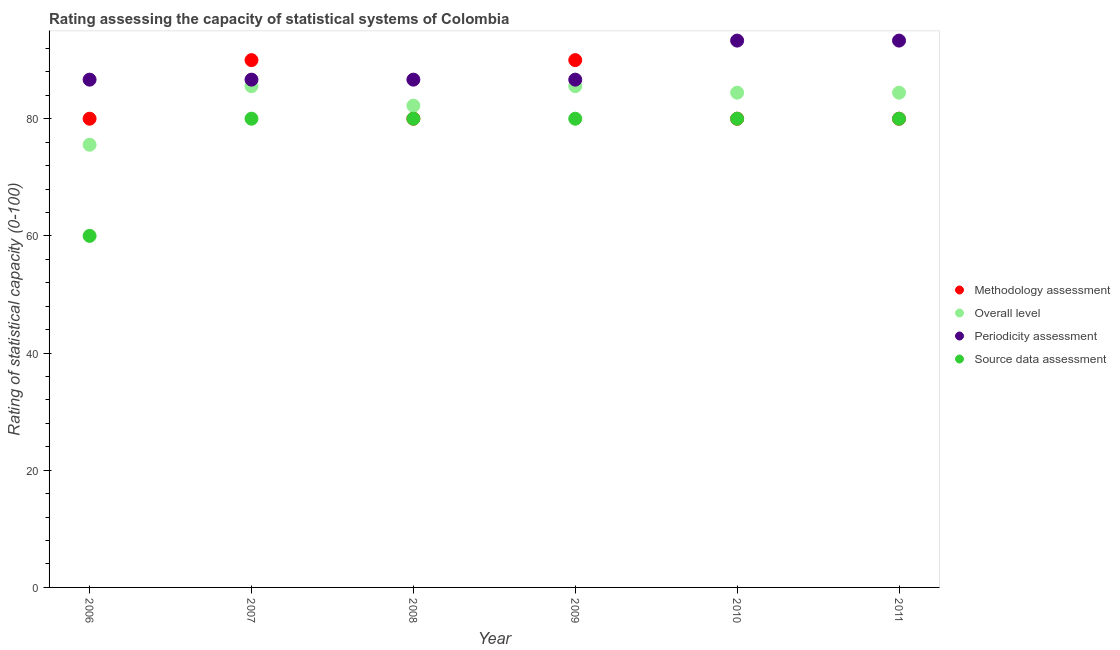What is the methodology assessment rating in 2010?
Your answer should be compact. 80. Across all years, what is the maximum methodology assessment rating?
Keep it short and to the point. 90. Across all years, what is the minimum methodology assessment rating?
Provide a succinct answer. 80. What is the total periodicity assessment rating in the graph?
Give a very brief answer. 533.33. What is the difference between the overall level rating in 2007 and that in 2010?
Your answer should be very brief. 1.11. What is the difference between the periodicity assessment rating in 2010 and the overall level rating in 2008?
Offer a very short reply. 11.11. What is the average periodicity assessment rating per year?
Offer a very short reply. 88.89. In the year 2009, what is the difference between the periodicity assessment rating and overall level rating?
Offer a terse response. 1.11. What is the ratio of the periodicity assessment rating in 2008 to that in 2010?
Offer a terse response. 0.93. Is the difference between the periodicity assessment rating in 2010 and 2011 greater than the difference between the overall level rating in 2010 and 2011?
Your response must be concise. No. What is the difference between the highest and the second highest overall level rating?
Your answer should be very brief. 0. What is the difference between the highest and the lowest source data assessment rating?
Offer a terse response. 20. In how many years, is the source data assessment rating greater than the average source data assessment rating taken over all years?
Give a very brief answer. 5. Is the sum of the overall level rating in 2009 and 2011 greater than the maximum source data assessment rating across all years?
Offer a very short reply. Yes. Is it the case that in every year, the sum of the overall level rating and source data assessment rating is greater than the sum of periodicity assessment rating and methodology assessment rating?
Provide a succinct answer. No. Is it the case that in every year, the sum of the methodology assessment rating and overall level rating is greater than the periodicity assessment rating?
Make the answer very short. Yes. Is the periodicity assessment rating strictly greater than the overall level rating over the years?
Offer a very short reply. Yes. How many dotlines are there?
Give a very brief answer. 4. How many years are there in the graph?
Your answer should be very brief. 6. What is the difference between two consecutive major ticks on the Y-axis?
Give a very brief answer. 20. Are the values on the major ticks of Y-axis written in scientific E-notation?
Ensure brevity in your answer.  No. Does the graph contain any zero values?
Your answer should be very brief. No. Does the graph contain grids?
Your answer should be very brief. No. Where does the legend appear in the graph?
Offer a very short reply. Center right. How many legend labels are there?
Your answer should be very brief. 4. What is the title of the graph?
Make the answer very short. Rating assessing the capacity of statistical systems of Colombia. What is the label or title of the X-axis?
Provide a short and direct response. Year. What is the label or title of the Y-axis?
Your answer should be compact. Rating of statistical capacity (0-100). What is the Rating of statistical capacity (0-100) in Methodology assessment in 2006?
Your response must be concise. 80. What is the Rating of statistical capacity (0-100) of Overall level in 2006?
Offer a terse response. 75.56. What is the Rating of statistical capacity (0-100) in Periodicity assessment in 2006?
Keep it short and to the point. 86.67. What is the Rating of statistical capacity (0-100) of Methodology assessment in 2007?
Your response must be concise. 90. What is the Rating of statistical capacity (0-100) of Overall level in 2007?
Provide a short and direct response. 85.56. What is the Rating of statistical capacity (0-100) in Periodicity assessment in 2007?
Keep it short and to the point. 86.67. What is the Rating of statistical capacity (0-100) of Methodology assessment in 2008?
Give a very brief answer. 80. What is the Rating of statistical capacity (0-100) in Overall level in 2008?
Provide a succinct answer. 82.22. What is the Rating of statistical capacity (0-100) of Periodicity assessment in 2008?
Keep it short and to the point. 86.67. What is the Rating of statistical capacity (0-100) in Source data assessment in 2008?
Ensure brevity in your answer.  80. What is the Rating of statistical capacity (0-100) in Overall level in 2009?
Keep it short and to the point. 85.56. What is the Rating of statistical capacity (0-100) in Periodicity assessment in 2009?
Give a very brief answer. 86.67. What is the Rating of statistical capacity (0-100) in Overall level in 2010?
Your response must be concise. 84.44. What is the Rating of statistical capacity (0-100) in Periodicity assessment in 2010?
Offer a terse response. 93.33. What is the Rating of statistical capacity (0-100) of Source data assessment in 2010?
Keep it short and to the point. 80. What is the Rating of statistical capacity (0-100) in Overall level in 2011?
Make the answer very short. 84.44. What is the Rating of statistical capacity (0-100) of Periodicity assessment in 2011?
Give a very brief answer. 93.33. Across all years, what is the maximum Rating of statistical capacity (0-100) in Overall level?
Ensure brevity in your answer.  85.56. Across all years, what is the maximum Rating of statistical capacity (0-100) of Periodicity assessment?
Offer a very short reply. 93.33. Across all years, what is the maximum Rating of statistical capacity (0-100) in Source data assessment?
Give a very brief answer. 80. Across all years, what is the minimum Rating of statistical capacity (0-100) of Overall level?
Offer a terse response. 75.56. Across all years, what is the minimum Rating of statistical capacity (0-100) of Periodicity assessment?
Your response must be concise. 86.67. What is the total Rating of statistical capacity (0-100) in Methodology assessment in the graph?
Your response must be concise. 500. What is the total Rating of statistical capacity (0-100) of Overall level in the graph?
Your response must be concise. 497.78. What is the total Rating of statistical capacity (0-100) in Periodicity assessment in the graph?
Give a very brief answer. 533.33. What is the total Rating of statistical capacity (0-100) in Source data assessment in the graph?
Your answer should be very brief. 460. What is the difference between the Rating of statistical capacity (0-100) in Overall level in 2006 and that in 2007?
Make the answer very short. -10. What is the difference between the Rating of statistical capacity (0-100) of Methodology assessment in 2006 and that in 2008?
Offer a terse response. 0. What is the difference between the Rating of statistical capacity (0-100) in Overall level in 2006 and that in 2008?
Make the answer very short. -6.67. What is the difference between the Rating of statistical capacity (0-100) of Source data assessment in 2006 and that in 2008?
Provide a succinct answer. -20. What is the difference between the Rating of statistical capacity (0-100) in Methodology assessment in 2006 and that in 2009?
Provide a short and direct response. -10. What is the difference between the Rating of statistical capacity (0-100) of Methodology assessment in 2006 and that in 2010?
Ensure brevity in your answer.  0. What is the difference between the Rating of statistical capacity (0-100) in Overall level in 2006 and that in 2010?
Keep it short and to the point. -8.89. What is the difference between the Rating of statistical capacity (0-100) in Periodicity assessment in 2006 and that in 2010?
Offer a very short reply. -6.67. What is the difference between the Rating of statistical capacity (0-100) in Source data assessment in 2006 and that in 2010?
Provide a short and direct response. -20. What is the difference between the Rating of statistical capacity (0-100) in Methodology assessment in 2006 and that in 2011?
Provide a short and direct response. 0. What is the difference between the Rating of statistical capacity (0-100) of Overall level in 2006 and that in 2011?
Provide a succinct answer. -8.89. What is the difference between the Rating of statistical capacity (0-100) in Periodicity assessment in 2006 and that in 2011?
Ensure brevity in your answer.  -6.67. What is the difference between the Rating of statistical capacity (0-100) in Source data assessment in 2007 and that in 2008?
Offer a terse response. 0. What is the difference between the Rating of statistical capacity (0-100) in Methodology assessment in 2007 and that in 2009?
Your response must be concise. 0. What is the difference between the Rating of statistical capacity (0-100) in Overall level in 2007 and that in 2009?
Keep it short and to the point. 0. What is the difference between the Rating of statistical capacity (0-100) in Periodicity assessment in 2007 and that in 2009?
Your response must be concise. 0. What is the difference between the Rating of statistical capacity (0-100) in Periodicity assessment in 2007 and that in 2010?
Make the answer very short. -6.67. What is the difference between the Rating of statistical capacity (0-100) in Methodology assessment in 2007 and that in 2011?
Make the answer very short. 10. What is the difference between the Rating of statistical capacity (0-100) in Overall level in 2007 and that in 2011?
Provide a short and direct response. 1.11. What is the difference between the Rating of statistical capacity (0-100) of Periodicity assessment in 2007 and that in 2011?
Ensure brevity in your answer.  -6.67. What is the difference between the Rating of statistical capacity (0-100) of Source data assessment in 2007 and that in 2011?
Keep it short and to the point. 0. What is the difference between the Rating of statistical capacity (0-100) of Methodology assessment in 2008 and that in 2009?
Your answer should be compact. -10. What is the difference between the Rating of statistical capacity (0-100) of Overall level in 2008 and that in 2009?
Ensure brevity in your answer.  -3.33. What is the difference between the Rating of statistical capacity (0-100) of Source data assessment in 2008 and that in 2009?
Ensure brevity in your answer.  0. What is the difference between the Rating of statistical capacity (0-100) of Methodology assessment in 2008 and that in 2010?
Make the answer very short. 0. What is the difference between the Rating of statistical capacity (0-100) in Overall level in 2008 and that in 2010?
Your answer should be compact. -2.22. What is the difference between the Rating of statistical capacity (0-100) in Periodicity assessment in 2008 and that in 2010?
Your answer should be compact. -6.67. What is the difference between the Rating of statistical capacity (0-100) of Source data assessment in 2008 and that in 2010?
Give a very brief answer. 0. What is the difference between the Rating of statistical capacity (0-100) of Overall level in 2008 and that in 2011?
Provide a succinct answer. -2.22. What is the difference between the Rating of statistical capacity (0-100) of Periodicity assessment in 2008 and that in 2011?
Keep it short and to the point. -6.67. What is the difference between the Rating of statistical capacity (0-100) of Methodology assessment in 2009 and that in 2010?
Keep it short and to the point. 10. What is the difference between the Rating of statistical capacity (0-100) in Overall level in 2009 and that in 2010?
Offer a terse response. 1.11. What is the difference between the Rating of statistical capacity (0-100) in Periodicity assessment in 2009 and that in 2010?
Your response must be concise. -6.67. What is the difference between the Rating of statistical capacity (0-100) in Overall level in 2009 and that in 2011?
Your answer should be compact. 1.11. What is the difference between the Rating of statistical capacity (0-100) in Periodicity assessment in 2009 and that in 2011?
Provide a short and direct response. -6.67. What is the difference between the Rating of statistical capacity (0-100) in Overall level in 2010 and that in 2011?
Your response must be concise. 0. What is the difference between the Rating of statistical capacity (0-100) in Methodology assessment in 2006 and the Rating of statistical capacity (0-100) in Overall level in 2007?
Keep it short and to the point. -5.56. What is the difference between the Rating of statistical capacity (0-100) in Methodology assessment in 2006 and the Rating of statistical capacity (0-100) in Periodicity assessment in 2007?
Offer a very short reply. -6.67. What is the difference between the Rating of statistical capacity (0-100) in Methodology assessment in 2006 and the Rating of statistical capacity (0-100) in Source data assessment in 2007?
Provide a short and direct response. 0. What is the difference between the Rating of statistical capacity (0-100) of Overall level in 2006 and the Rating of statistical capacity (0-100) of Periodicity assessment in 2007?
Give a very brief answer. -11.11. What is the difference between the Rating of statistical capacity (0-100) in Overall level in 2006 and the Rating of statistical capacity (0-100) in Source data assessment in 2007?
Your answer should be compact. -4.44. What is the difference between the Rating of statistical capacity (0-100) in Methodology assessment in 2006 and the Rating of statistical capacity (0-100) in Overall level in 2008?
Provide a succinct answer. -2.22. What is the difference between the Rating of statistical capacity (0-100) of Methodology assessment in 2006 and the Rating of statistical capacity (0-100) of Periodicity assessment in 2008?
Keep it short and to the point. -6.67. What is the difference between the Rating of statistical capacity (0-100) in Overall level in 2006 and the Rating of statistical capacity (0-100) in Periodicity assessment in 2008?
Make the answer very short. -11.11. What is the difference between the Rating of statistical capacity (0-100) in Overall level in 2006 and the Rating of statistical capacity (0-100) in Source data assessment in 2008?
Keep it short and to the point. -4.44. What is the difference between the Rating of statistical capacity (0-100) of Periodicity assessment in 2006 and the Rating of statistical capacity (0-100) of Source data assessment in 2008?
Provide a succinct answer. 6.67. What is the difference between the Rating of statistical capacity (0-100) of Methodology assessment in 2006 and the Rating of statistical capacity (0-100) of Overall level in 2009?
Give a very brief answer. -5.56. What is the difference between the Rating of statistical capacity (0-100) in Methodology assessment in 2006 and the Rating of statistical capacity (0-100) in Periodicity assessment in 2009?
Make the answer very short. -6.67. What is the difference between the Rating of statistical capacity (0-100) of Overall level in 2006 and the Rating of statistical capacity (0-100) of Periodicity assessment in 2009?
Keep it short and to the point. -11.11. What is the difference between the Rating of statistical capacity (0-100) in Overall level in 2006 and the Rating of statistical capacity (0-100) in Source data assessment in 2009?
Offer a terse response. -4.44. What is the difference between the Rating of statistical capacity (0-100) in Methodology assessment in 2006 and the Rating of statistical capacity (0-100) in Overall level in 2010?
Your response must be concise. -4.44. What is the difference between the Rating of statistical capacity (0-100) in Methodology assessment in 2006 and the Rating of statistical capacity (0-100) in Periodicity assessment in 2010?
Make the answer very short. -13.33. What is the difference between the Rating of statistical capacity (0-100) in Overall level in 2006 and the Rating of statistical capacity (0-100) in Periodicity assessment in 2010?
Offer a very short reply. -17.78. What is the difference between the Rating of statistical capacity (0-100) in Overall level in 2006 and the Rating of statistical capacity (0-100) in Source data assessment in 2010?
Provide a short and direct response. -4.44. What is the difference between the Rating of statistical capacity (0-100) in Methodology assessment in 2006 and the Rating of statistical capacity (0-100) in Overall level in 2011?
Make the answer very short. -4.44. What is the difference between the Rating of statistical capacity (0-100) in Methodology assessment in 2006 and the Rating of statistical capacity (0-100) in Periodicity assessment in 2011?
Provide a short and direct response. -13.33. What is the difference between the Rating of statistical capacity (0-100) of Overall level in 2006 and the Rating of statistical capacity (0-100) of Periodicity assessment in 2011?
Your answer should be very brief. -17.78. What is the difference between the Rating of statistical capacity (0-100) of Overall level in 2006 and the Rating of statistical capacity (0-100) of Source data assessment in 2011?
Keep it short and to the point. -4.44. What is the difference between the Rating of statistical capacity (0-100) of Periodicity assessment in 2006 and the Rating of statistical capacity (0-100) of Source data assessment in 2011?
Make the answer very short. 6.67. What is the difference between the Rating of statistical capacity (0-100) of Methodology assessment in 2007 and the Rating of statistical capacity (0-100) of Overall level in 2008?
Offer a terse response. 7.78. What is the difference between the Rating of statistical capacity (0-100) in Methodology assessment in 2007 and the Rating of statistical capacity (0-100) in Periodicity assessment in 2008?
Your answer should be very brief. 3.33. What is the difference between the Rating of statistical capacity (0-100) of Methodology assessment in 2007 and the Rating of statistical capacity (0-100) of Source data assessment in 2008?
Your answer should be very brief. 10. What is the difference between the Rating of statistical capacity (0-100) of Overall level in 2007 and the Rating of statistical capacity (0-100) of Periodicity assessment in 2008?
Offer a terse response. -1.11. What is the difference between the Rating of statistical capacity (0-100) of Overall level in 2007 and the Rating of statistical capacity (0-100) of Source data assessment in 2008?
Your answer should be very brief. 5.56. What is the difference between the Rating of statistical capacity (0-100) of Periodicity assessment in 2007 and the Rating of statistical capacity (0-100) of Source data assessment in 2008?
Keep it short and to the point. 6.67. What is the difference between the Rating of statistical capacity (0-100) in Methodology assessment in 2007 and the Rating of statistical capacity (0-100) in Overall level in 2009?
Your response must be concise. 4.44. What is the difference between the Rating of statistical capacity (0-100) in Methodology assessment in 2007 and the Rating of statistical capacity (0-100) in Periodicity assessment in 2009?
Provide a short and direct response. 3.33. What is the difference between the Rating of statistical capacity (0-100) in Overall level in 2007 and the Rating of statistical capacity (0-100) in Periodicity assessment in 2009?
Provide a short and direct response. -1.11. What is the difference between the Rating of statistical capacity (0-100) of Overall level in 2007 and the Rating of statistical capacity (0-100) of Source data assessment in 2009?
Your answer should be compact. 5.56. What is the difference between the Rating of statistical capacity (0-100) in Periodicity assessment in 2007 and the Rating of statistical capacity (0-100) in Source data assessment in 2009?
Give a very brief answer. 6.67. What is the difference between the Rating of statistical capacity (0-100) of Methodology assessment in 2007 and the Rating of statistical capacity (0-100) of Overall level in 2010?
Offer a very short reply. 5.56. What is the difference between the Rating of statistical capacity (0-100) in Overall level in 2007 and the Rating of statistical capacity (0-100) in Periodicity assessment in 2010?
Offer a terse response. -7.78. What is the difference between the Rating of statistical capacity (0-100) of Overall level in 2007 and the Rating of statistical capacity (0-100) of Source data assessment in 2010?
Offer a very short reply. 5.56. What is the difference between the Rating of statistical capacity (0-100) in Periodicity assessment in 2007 and the Rating of statistical capacity (0-100) in Source data assessment in 2010?
Offer a terse response. 6.67. What is the difference between the Rating of statistical capacity (0-100) in Methodology assessment in 2007 and the Rating of statistical capacity (0-100) in Overall level in 2011?
Provide a short and direct response. 5.56. What is the difference between the Rating of statistical capacity (0-100) in Methodology assessment in 2007 and the Rating of statistical capacity (0-100) in Periodicity assessment in 2011?
Your answer should be very brief. -3.33. What is the difference between the Rating of statistical capacity (0-100) in Overall level in 2007 and the Rating of statistical capacity (0-100) in Periodicity assessment in 2011?
Your answer should be compact. -7.78. What is the difference between the Rating of statistical capacity (0-100) of Overall level in 2007 and the Rating of statistical capacity (0-100) of Source data assessment in 2011?
Make the answer very short. 5.56. What is the difference between the Rating of statistical capacity (0-100) in Periodicity assessment in 2007 and the Rating of statistical capacity (0-100) in Source data assessment in 2011?
Give a very brief answer. 6.67. What is the difference between the Rating of statistical capacity (0-100) in Methodology assessment in 2008 and the Rating of statistical capacity (0-100) in Overall level in 2009?
Provide a short and direct response. -5.56. What is the difference between the Rating of statistical capacity (0-100) of Methodology assessment in 2008 and the Rating of statistical capacity (0-100) of Periodicity assessment in 2009?
Your answer should be compact. -6.67. What is the difference between the Rating of statistical capacity (0-100) in Methodology assessment in 2008 and the Rating of statistical capacity (0-100) in Source data assessment in 2009?
Your response must be concise. 0. What is the difference between the Rating of statistical capacity (0-100) in Overall level in 2008 and the Rating of statistical capacity (0-100) in Periodicity assessment in 2009?
Offer a very short reply. -4.44. What is the difference between the Rating of statistical capacity (0-100) in Overall level in 2008 and the Rating of statistical capacity (0-100) in Source data assessment in 2009?
Your answer should be compact. 2.22. What is the difference between the Rating of statistical capacity (0-100) in Methodology assessment in 2008 and the Rating of statistical capacity (0-100) in Overall level in 2010?
Make the answer very short. -4.44. What is the difference between the Rating of statistical capacity (0-100) in Methodology assessment in 2008 and the Rating of statistical capacity (0-100) in Periodicity assessment in 2010?
Offer a very short reply. -13.33. What is the difference between the Rating of statistical capacity (0-100) in Methodology assessment in 2008 and the Rating of statistical capacity (0-100) in Source data assessment in 2010?
Keep it short and to the point. 0. What is the difference between the Rating of statistical capacity (0-100) in Overall level in 2008 and the Rating of statistical capacity (0-100) in Periodicity assessment in 2010?
Offer a very short reply. -11.11. What is the difference between the Rating of statistical capacity (0-100) of Overall level in 2008 and the Rating of statistical capacity (0-100) of Source data assessment in 2010?
Give a very brief answer. 2.22. What is the difference between the Rating of statistical capacity (0-100) in Methodology assessment in 2008 and the Rating of statistical capacity (0-100) in Overall level in 2011?
Provide a short and direct response. -4.44. What is the difference between the Rating of statistical capacity (0-100) in Methodology assessment in 2008 and the Rating of statistical capacity (0-100) in Periodicity assessment in 2011?
Make the answer very short. -13.33. What is the difference between the Rating of statistical capacity (0-100) of Overall level in 2008 and the Rating of statistical capacity (0-100) of Periodicity assessment in 2011?
Your answer should be compact. -11.11. What is the difference between the Rating of statistical capacity (0-100) in Overall level in 2008 and the Rating of statistical capacity (0-100) in Source data assessment in 2011?
Provide a short and direct response. 2.22. What is the difference between the Rating of statistical capacity (0-100) in Periodicity assessment in 2008 and the Rating of statistical capacity (0-100) in Source data assessment in 2011?
Offer a terse response. 6.67. What is the difference between the Rating of statistical capacity (0-100) of Methodology assessment in 2009 and the Rating of statistical capacity (0-100) of Overall level in 2010?
Give a very brief answer. 5.56. What is the difference between the Rating of statistical capacity (0-100) in Methodology assessment in 2009 and the Rating of statistical capacity (0-100) in Source data assessment in 2010?
Your response must be concise. 10. What is the difference between the Rating of statistical capacity (0-100) in Overall level in 2009 and the Rating of statistical capacity (0-100) in Periodicity assessment in 2010?
Ensure brevity in your answer.  -7.78. What is the difference between the Rating of statistical capacity (0-100) of Overall level in 2009 and the Rating of statistical capacity (0-100) of Source data assessment in 2010?
Make the answer very short. 5.56. What is the difference between the Rating of statistical capacity (0-100) of Methodology assessment in 2009 and the Rating of statistical capacity (0-100) of Overall level in 2011?
Your answer should be very brief. 5.56. What is the difference between the Rating of statistical capacity (0-100) in Methodology assessment in 2009 and the Rating of statistical capacity (0-100) in Periodicity assessment in 2011?
Your response must be concise. -3.33. What is the difference between the Rating of statistical capacity (0-100) in Methodology assessment in 2009 and the Rating of statistical capacity (0-100) in Source data assessment in 2011?
Offer a very short reply. 10. What is the difference between the Rating of statistical capacity (0-100) of Overall level in 2009 and the Rating of statistical capacity (0-100) of Periodicity assessment in 2011?
Make the answer very short. -7.78. What is the difference between the Rating of statistical capacity (0-100) in Overall level in 2009 and the Rating of statistical capacity (0-100) in Source data assessment in 2011?
Keep it short and to the point. 5.56. What is the difference between the Rating of statistical capacity (0-100) of Periodicity assessment in 2009 and the Rating of statistical capacity (0-100) of Source data assessment in 2011?
Your response must be concise. 6.67. What is the difference between the Rating of statistical capacity (0-100) of Methodology assessment in 2010 and the Rating of statistical capacity (0-100) of Overall level in 2011?
Keep it short and to the point. -4.44. What is the difference between the Rating of statistical capacity (0-100) of Methodology assessment in 2010 and the Rating of statistical capacity (0-100) of Periodicity assessment in 2011?
Ensure brevity in your answer.  -13.33. What is the difference between the Rating of statistical capacity (0-100) of Overall level in 2010 and the Rating of statistical capacity (0-100) of Periodicity assessment in 2011?
Make the answer very short. -8.89. What is the difference between the Rating of statistical capacity (0-100) in Overall level in 2010 and the Rating of statistical capacity (0-100) in Source data assessment in 2011?
Provide a succinct answer. 4.44. What is the difference between the Rating of statistical capacity (0-100) in Periodicity assessment in 2010 and the Rating of statistical capacity (0-100) in Source data assessment in 2011?
Provide a short and direct response. 13.33. What is the average Rating of statistical capacity (0-100) in Methodology assessment per year?
Keep it short and to the point. 83.33. What is the average Rating of statistical capacity (0-100) of Overall level per year?
Offer a terse response. 82.96. What is the average Rating of statistical capacity (0-100) in Periodicity assessment per year?
Provide a succinct answer. 88.89. What is the average Rating of statistical capacity (0-100) of Source data assessment per year?
Ensure brevity in your answer.  76.67. In the year 2006, what is the difference between the Rating of statistical capacity (0-100) of Methodology assessment and Rating of statistical capacity (0-100) of Overall level?
Keep it short and to the point. 4.44. In the year 2006, what is the difference between the Rating of statistical capacity (0-100) of Methodology assessment and Rating of statistical capacity (0-100) of Periodicity assessment?
Keep it short and to the point. -6.67. In the year 2006, what is the difference between the Rating of statistical capacity (0-100) in Methodology assessment and Rating of statistical capacity (0-100) in Source data assessment?
Provide a succinct answer. 20. In the year 2006, what is the difference between the Rating of statistical capacity (0-100) in Overall level and Rating of statistical capacity (0-100) in Periodicity assessment?
Your answer should be compact. -11.11. In the year 2006, what is the difference between the Rating of statistical capacity (0-100) in Overall level and Rating of statistical capacity (0-100) in Source data assessment?
Your answer should be very brief. 15.56. In the year 2006, what is the difference between the Rating of statistical capacity (0-100) of Periodicity assessment and Rating of statistical capacity (0-100) of Source data assessment?
Provide a succinct answer. 26.67. In the year 2007, what is the difference between the Rating of statistical capacity (0-100) in Methodology assessment and Rating of statistical capacity (0-100) in Overall level?
Provide a short and direct response. 4.44. In the year 2007, what is the difference between the Rating of statistical capacity (0-100) of Methodology assessment and Rating of statistical capacity (0-100) of Periodicity assessment?
Offer a terse response. 3.33. In the year 2007, what is the difference between the Rating of statistical capacity (0-100) of Overall level and Rating of statistical capacity (0-100) of Periodicity assessment?
Your answer should be very brief. -1.11. In the year 2007, what is the difference between the Rating of statistical capacity (0-100) in Overall level and Rating of statistical capacity (0-100) in Source data assessment?
Ensure brevity in your answer.  5.56. In the year 2007, what is the difference between the Rating of statistical capacity (0-100) in Periodicity assessment and Rating of statistical capacity (0-100) in Source data assessment?
Your answer should be compact. 6.67. In the year 2008, what is the difference between the Rating of statistical capacity (0-100) of Methodology assessment and Rating of statistical capacity (0-100) of Overall level?
Offer a terse response. -2.22. In the year 2008, what is the difference between the Rating of statistical capacity (0-100) of Methodology assessment and Rating of statistical capacity (0-100) of Periodicity assessment?
Offer a terse response. -6.67. In the year 2008, what is the difference between the Rating of statistical capacity (0-100) in Methodology assessment and Rating of statistical capacity (0-100) in Source data assessment?
Keep it short and to the point. 0. In the year 2008, what is the difference between the Rating of statistical capacity (0-100) of Overall level and Rating of statistical capacity (0-100) of Periodicity assessment?
Your answer should be very brief. -4.44. In the year 2008, what is the difference between the Rating of statistical capacity (0-100) in Overall level and Rating of statistical capacity (0-100) in Source data assessment?
Provide a succinct answer. 2.22. In the year 2008, what is the difference between the Rating of statistical capacity (0-100) in Periodicity assessment and Rating of statistical capacity (0-100) in Source data assessment?
Your response must be concise. 6.67. In the year 2009, what is the difference between the Rating of statistical capacity (0-100) of Methodology assessment and Rating of statistical capacity (0-100) of Overall level?
Make the answer very short. 4.44. In the year 2009, what is the difference between the Rating of statistical capacity (0-100) in Overall level and Rating of statistical capacity (0-100) in Periodicity assessment?
Ensure brevity in your answer.  -1.11. In the year 2009, what is the difference between the Rating of statistical capacity (0-100) of Overall level and Rating of statistical capacity (0-100) of Source data assessment?
Make the answer very short. 5.56. In the year 2009, what is the difference between the Rating of statistical capacity (0-100) of Periodicity assessment and Rating of statistical capacity (0-100) of Source data assessment?
Your response must be concise. 6.67. In the year 2010, what is the difference between the Rating of statistical capacity (0-100) of Methodology assessment and Rating of statistical capacity (0-100) of Overall level?
Keep it short and to the point. -4.44. In the year 2010, what is the difference between the Rating of statistical capacity (0-100) in Methodology assessment and Rating of statistical capacity (0-100) in Periodicity assessment?
Ensure brevity in your answer.  -13.33. In the year 2010, what is the difference between the Rating of statistical capacity (0-100) of Methodology assessment and Rating of statistical capacity (0-100) of Source data assessment?
Ensure brevity in your answer.  0. In the year 2010, what is the difference between the Rating of statistical capacity (0-100) of Overall level and Rating of statistical capacity (0-100) of Periodicity assessment?
Provide a succinct answer. -8.89. In the year 2010, what is the difference between the Rating of statistical capacity (0-100) in Overall level and Rating of statistical capacity (0-100) in Source data assessment?
Provide a succinct answer. 4.44. In the year 2010, what is the difference between the Rating of statistical capacity (0-100) of Periodicity assessment and Rating of statistical capacity (0-100) of Source data assessment?
Provide a short and direct response. 13.33. In the year 2011, what is the difference between the Rating of statistical capacity (0-100) in Methodology assessment and Rating of statistical capacity (0-100) in Overall level?
Offer a very short reply. -4.44. In the year 2011, what is the difference between the Rating of statistical capacity (0-100) of Methodology assessment and Rating of statistical capacity (0-100) of Periodicity assessment?
Offer a terse response. -13.33. In the year 2011, what is the difference between the Rating of statistical capacity (0-100) of Overall level and Rating of statistical capacity (0-100) of Periodicity assessment?
Give a very brief answer. -8.89. In the year 2011, what is the difference between the Rating of statistical capacity (0-100) of Overall level and Rating of statistical capacity (0-100) of Source data assessment?
Offer a terse response. 4.44. In the year 2011, what is the difference between the Rating of statistical capacity (0-100) of Periodicity assessment and Rating of statistical capacity (0-100) of Source data assessment?
Ensure brevity in your answer.  13.33. What is the ratio of the Rating of statistical capacity (0-100) in Methodology assessment in 2006 to that in 2007?
Your answer should be compact. 0.89. What is the ratio of the Rating of statistical capacity (0-100) in Overall level in 2006 to that in 2007?
Ensure brevity in your answer.  0.88. What is the ratio of the Rating of statistical capacity (0-100) of Source data assessment in 2006 to that in 2007?
Your response must be concise. 0.75. What is the ratio of the Rating of statistical capacity (0-100) in Overall level in 2006 to that in 2008?
Ensure brevity in your answer.  0.92. What is the ratio of the Rating of statistical capacity (0-100) of Periodicity assessment in 2006 to that in 2008?
Provide a succinct answer. 1. What is the ratio of the Rating of statistical capacity (0-100) of Overall level in 2006 to that in 2009?
Your answer should be compact. 0.88. What is the ratio of the Rating of statistical capacity (0-100) of Overall level in 2006 to that in 2010?
Offer a terse response. 0.89. What is the ratio of the Rating of statistical capacity (0-100) in Overall level in 2006 to that in 2011?
Your response must be concise. 0.89. What is the ratio of the Rating of statistical capacity (0-100) in Source data assessment in 2006 to that in 2011?
Ensure brevity in your answer.  0.75. What is the ratio of the Rating of statistical capacity (0-100) of Overall level in 2007 to that in 2008?
Your response must be concise. 1.04. What is the ratio of the Rating of statistical capacity (0-100) in Methodology assessment in 2007 to that in 2009?
Ensure brevity in your answer.  1. What is the ratio of the Rating of statistical capacity (0-100) in Periodicity assessment in 2007 to that in 2009?
Keep it short and to the point. 1. What is the ratio of the Rating of statistical capacity (0-100) of Source data assessment in 2007 to that in 2009?
Give a very brief answer. 1. What is the ratio of the Rating of statistical capacity (0-100) in Overall level in 2007 to that in 2010?
Offer a terse response. 1.01. What is the ratio of the Rating of statistical capacity (0-100) in Source data assessment in 2007 to that in 2010?
Your answer should be compact. 1. What is the ratio of the Rating of statistical capacity (0-100) in Overall level in 2007 to that in 2011?
Offer a terse response. 1.01. What is the ratio of the Rating of statistical capacity (0-100) in Methodology assessment in 2008 to that in 2009?
Your response must be concise. 0.89. What is the ratio of the Rating of statistical capacity (0-100) of Methodology assessment in 2008 to that in 2010?
Ensure brevity in your answer.  1. What is the ratio of the Rating of statistical capacity (0-100) of Overall level in 2008 to that in 2010?
Keep it short and to the point. 0.97. What is the ratio of the Rating of statistical capacity (0-100) in Source data assessment in 2008 to that in 2010?
Keep it short and to the point. 1. What is the ratio of the Rating of statistical capacity (0-100) of Overall level in 2008 to that in 2011?
Provide a short and direct response. 0.97. What is the ratio of the Rating of statistical capacity (0-100) in Periodicity assessment in 2008 to that in 2011?
Keep it short and to the point. 0.93. What is the ratio of the Rating of statistical capacity (0-100) in Source data assessment in 2008 to that in 2011?
Your response must be concise. 1. What is the ratio of the Rating of statistical capacity (0-100) in Overall level in 2009 to that in 2010?
Your response must be concise. 1.01. What is the ratio of the Rating of statistical capacity (0-100) in Periodicity assessment in 2009 to that in 2010?
Your answer should be compact. 0.93. What is the ratio of the Rating of statistical capacity (0-100) in Source data assessment in 2009 to that in 2010?
Provide a succinct answer. 1. What is the ratio of the Rating of statistical capacity (0-100) of Methodology assessment in 2009 to that in 2011?
Give a very brief answer. 1.12. What is the ratio of the Rating of statistical capacity (0-100) of Overall level in 2009 to that in 2011?
Give a very brief answer. 1.01. What is the ratio of the Rating of statistical capacity (0-100) in Periodicity assessment in 2009 to that in 2011?
Keep it short and to the point. 0.93. What is the difference between the highest and the second highest Rating of statistical capacity (0-100) in Overall level?
Your answer should be compact. 0. What is the difference between the highest and the second highest Rating of statistical capacity (0-100) of Periodicity assessment?
Provide a short and direct response. 0. What is the difference between the highest and the lowest Rating of statistical capacity (0-100) in Source data assessment?
Offer a terse response. 20. 